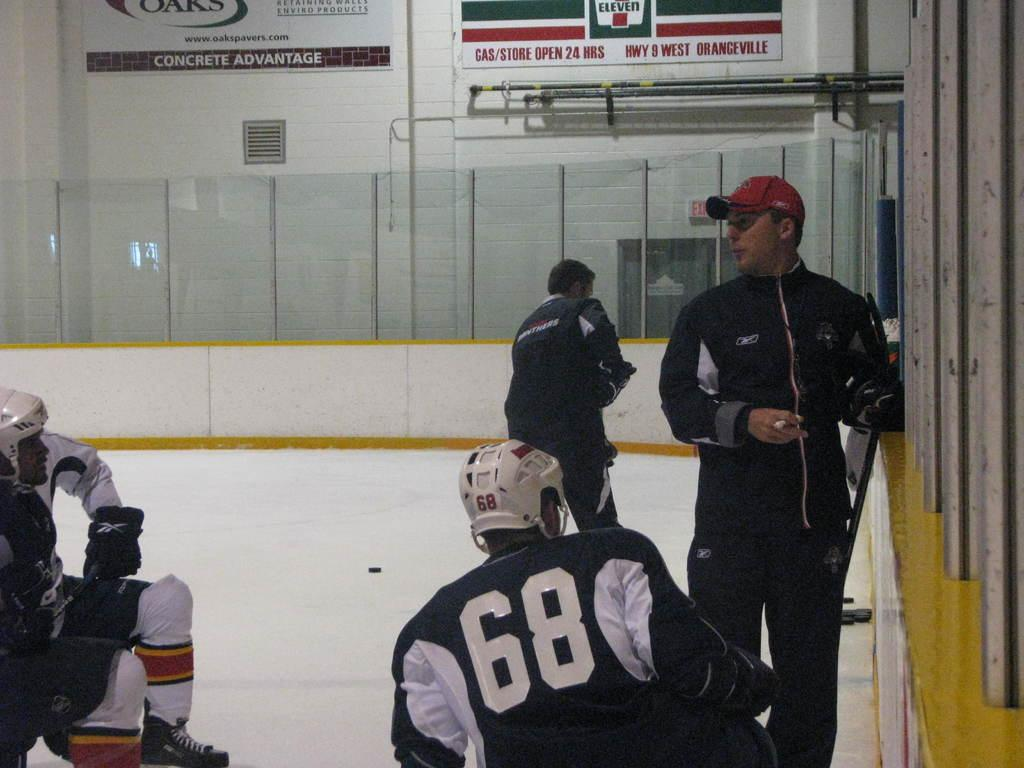<image>
Give a short and clear explanation of the subsequent image. Hockey players are on the ice in an arena that features an advertisement for 7 Eleven. 